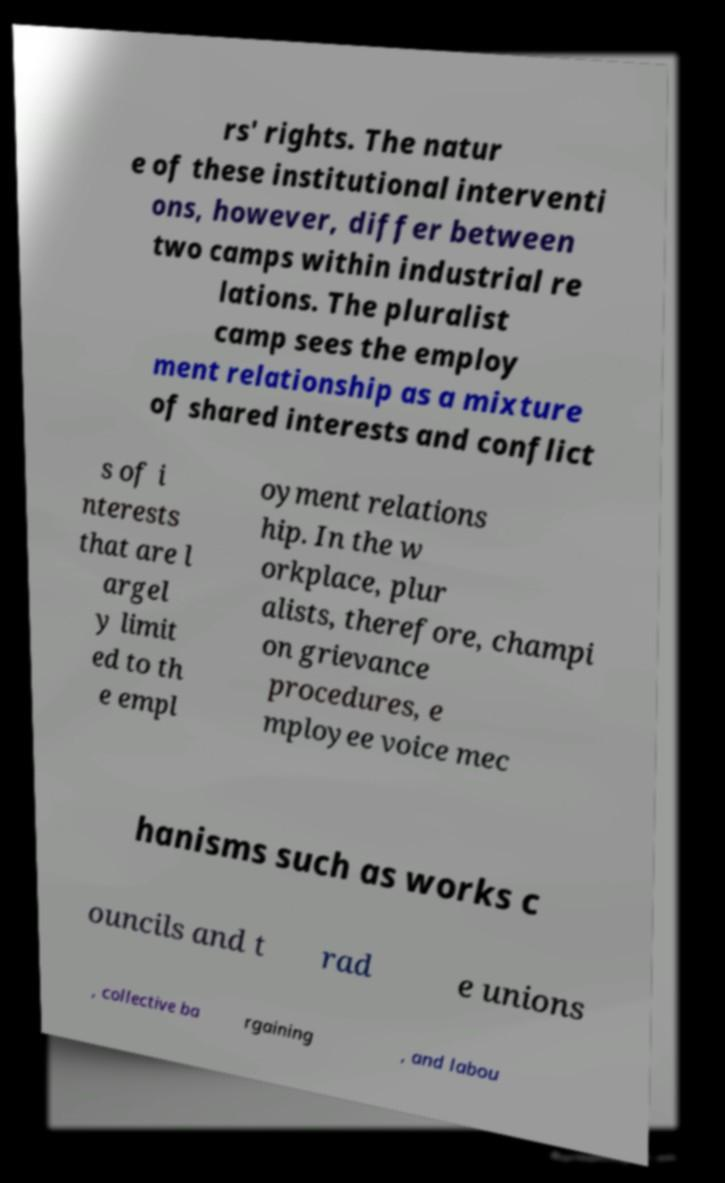For documentation purposes, I need the text within this image transcribed. Could you provide that? rs' rights. The natur e of these institutional interventi ons, however, differ between two camps within industrial re lations. The pluralist camp sees the employ ment relationship as a mixture of shared interests and conflict s of i nterests that are l argel y limit ed to th e empl oyment relations hip. In the w orkplace, plur alists, therefore, champi on grievance procedures, e mployee voice mec hanisms such as works c ouncils and t rad e unions , collective ba rgaining , and labou 